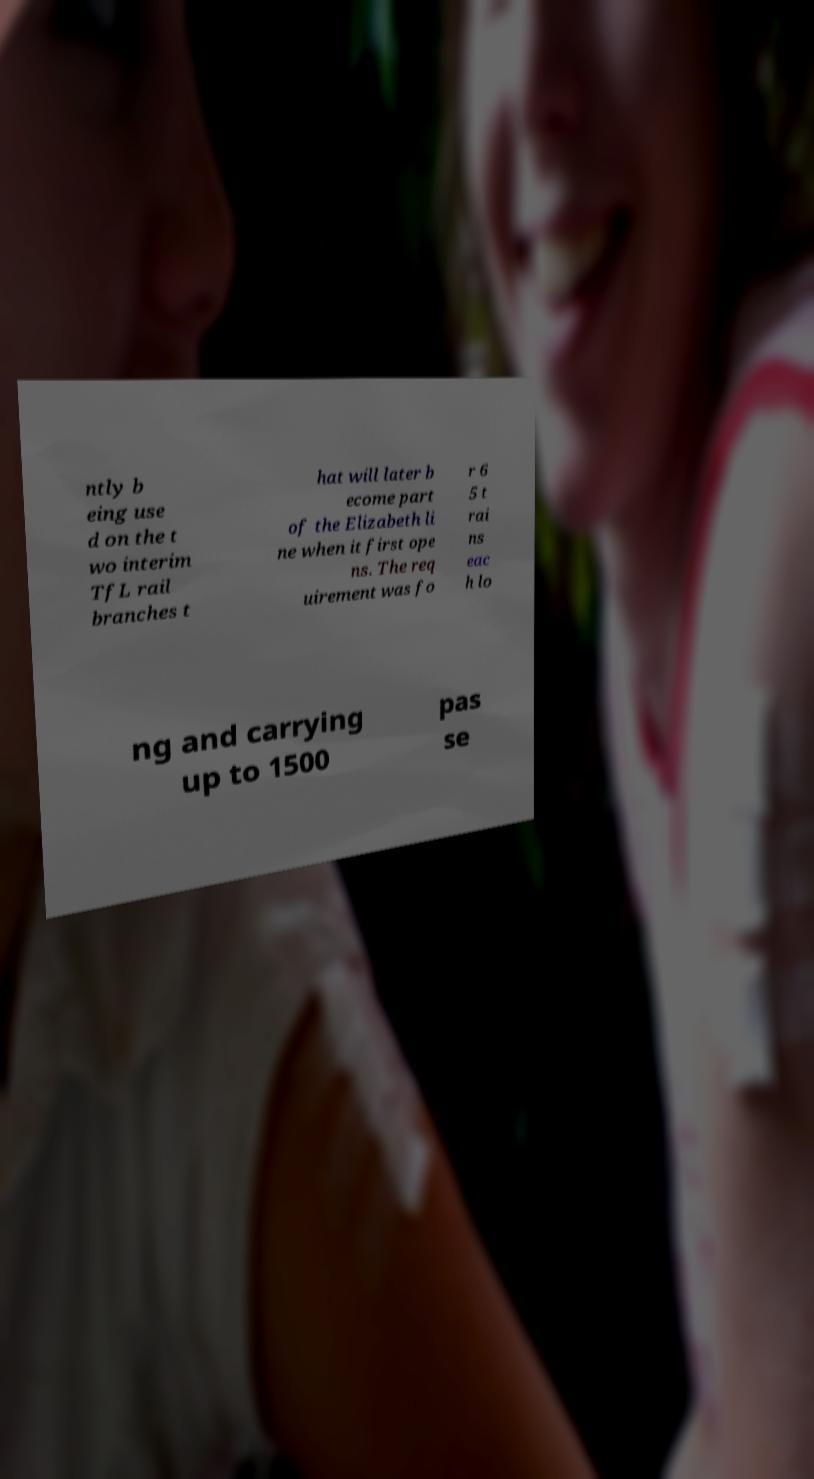I need the written content from this picture converted into text. Can you do that? ntly b eing use d on the t wo interim TfL rail branches t hat will later b ecome part of the Elizabeth li ne when it first ope ns. The req uirement was fo r 6 5 t rai ns eac h lo ng and carrying up to 1500 pas se 